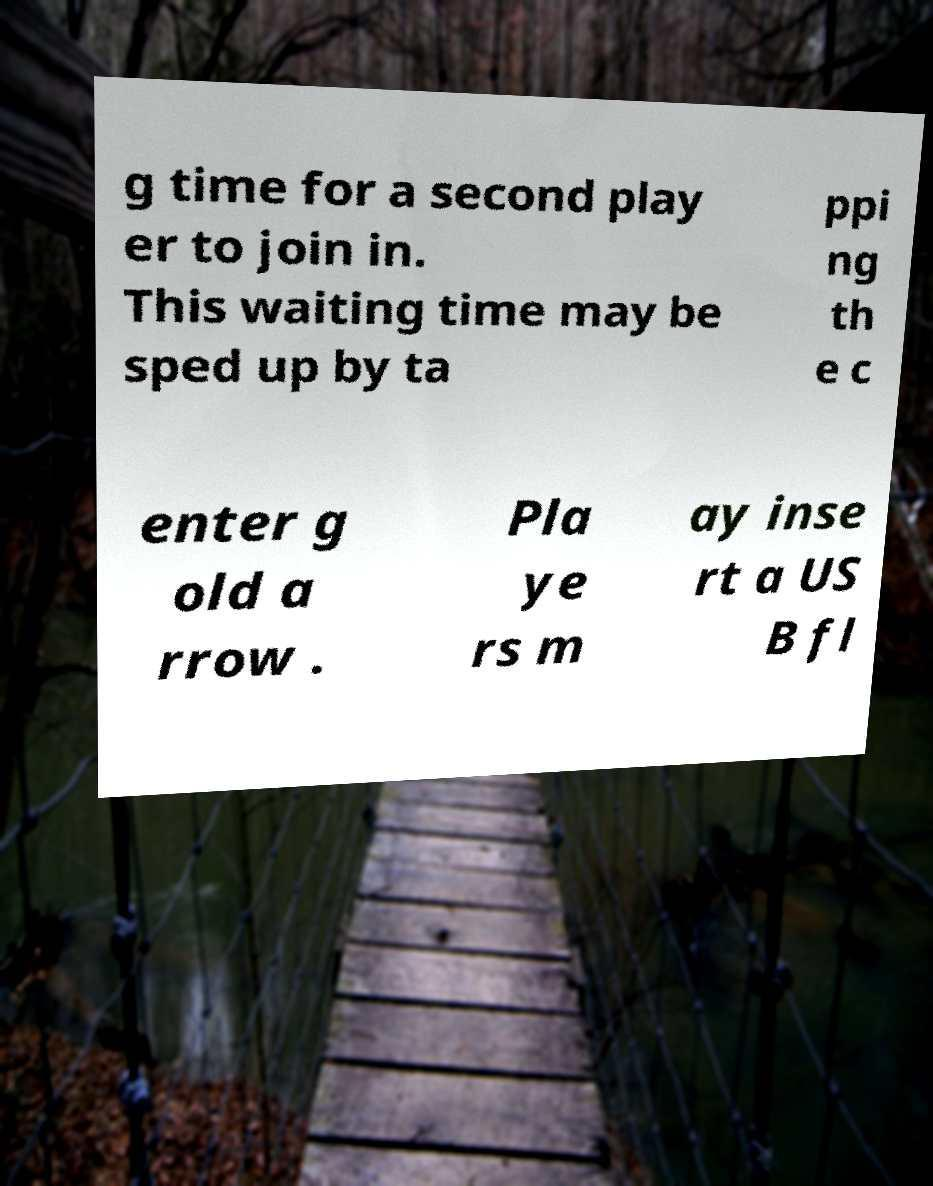Could you extract and type out the text from this image? g time for a second play er to join in. This waiting time may be sped up by ta ppi ng th e c enter g old a rrow . Pla ye rs m ay inse rt a US B fl 